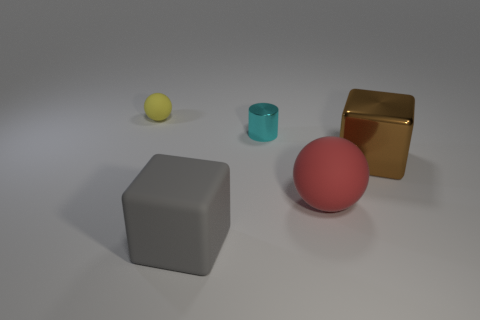What number of other objects are the same color as the big ball?
Your response must be concise. 0. What shape is the brown shiny thing that is the same size as the gray rubber thing?
Your answer should be compact. Cube. What number of tiny things are either yellow objects or gray cubes?
Give a very brief answer. 1. There is a rubber sphere behind the ball on the right side of the big gray rubber block; is there a small cyan object behind it?
Provide a succinct answer. No. Are there any yellow matte cylinders that have the same size as the yellow rubber sphere?
Your response must be concise. No. There is a brown block that is the same size as the red matte thing; what material is it?
Provide a short and direct response. Metal. Do the yellow sphere and the ball right of the big gray rubber object have the same size?
Offer a very short reply. No. How many metal things are either cyan things or small blue cubes?
Your response must be concise. 1. How many yellow matte things are the same shape as the red matte thing?
Provide a succinct answer. 1. There is a ball right of the small matte ball; is it the same size as the metallic object that is to the right of the metal cylinder?
Your answer should be compact. Yes. 